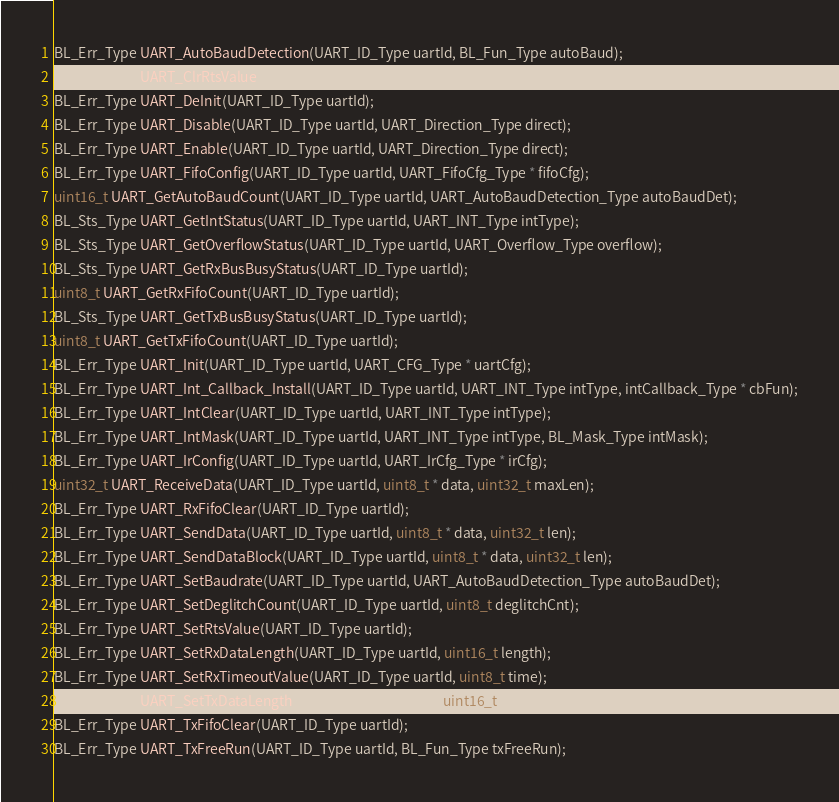<code> <loc_0><loc_0><loc_500><loc_500><_C_>
BL_Err_Type UART_AutoBaudDetection(UART_ID_Type uartId, BL_Fun_Type autoBaud);
BL_Err_Type UART_ClrRtsValue(UART_ID_Type uartId);
BL_Err_Type UART_DeInit(UART_ID_Type uartId);
BL_Err_Type UART_Disable(UART_ID_Type uartId, UART_Direction_Type direct);
BL_Err_Type UART_Enable(UART_ID_Type uartId, UART_Direction_Type direct);
BL_Err_Type UART_FifoConfig(UART_ID_Type uartId, UART_FifoCfg_Type * fifoCfg);
uint16_t UART_GetAutoBaudCount(UART_ID_Type uartId, UART_AutoBaudDetection_Type autoBaudDet);
BL_Sts_Type UART_GetIntStatus(UART_ID_Type uartId, UART_INT_Type intType);
BL_Sts_Type UART_GetOverflowStatus(UART_ID_Type uartId, UART_Overflow_Type overflow);
BL_Sts_Type UART_GetRxBusBusyStatus(UART_ID_Type uartId);
uint8_t UART_GetRxFifoCount(UART_ID_Type uartId);
BL_Sts_Type UART_GetTxBusBusyStatus(UART_ID_Type uartId);
uint8_t UART_GetTxFifoCount(UART_ID_Type uartId);
BL_Err_Type UART_Init(UART_ID_Type uartId, UART_CFG_Type * uartCfg);
BL_Err_Type UART_Int_Callback_Install(UART_ID_Type uartId, UART_INT_Type intType, intCallback_Type * cbFun);
BL_Err_Type UART_IntClear(UART_ID_Type uartId, UART_INT_Type intType);
BL_Err_Type UART_IntMask(UART_ID_Type uartId, UART_INT_Type intType, BL_Mask_Type intMask);
BL_Err_Type UART_IrConfig(UART_ID_Type uartId, UART_IrCfg_Type * irCfg);
uint32_t UART_ReceiveData(UART_ID_Type uartId, uint8_t * data, uint32_t maxLen);
BL_Err_Type UART_RxFifoClear(UART_ID_Type uartId);
BL_Err_Type UART_SendData(UART_ID_Type uartId, uint8_t * data, uint32_t len);
BL_Err_Type UART_SendDataBlock(UART_ID_Type uartId, uint8_t * data, uint32_t len);
BL_Err_Type UART_SetBaudrate(UART_ID_Type uartId, UART_AutoBaudDetection_Type autoBaudDet);
BL_Err_Type UART_SetDeglitchCount(UART_ID_Type uartId, uint8_t deglitchCnt);
BL_Err_Type UART_SetRtsValue(UART_ID_Type uartId);
BL_Err_Type UART_SetRxDataLength(UART_ID_Type uartId, uint16_t length);
BL_Err_Type UART_SetRxTimeoutValue(UART_ID_Type uartId, uint8_t time);
BL_Err_Type UART_SetTxDataLength(UART_ID_Type uartId, uint16_t length);
BL_Err_Type UART_TxFifoClear(UART_ID_Type uartId);
BL_Err_Type UART_TxFreeRun(UART_ID_Type uartId, BL_Fun_Type txFreeRun);
</code> 